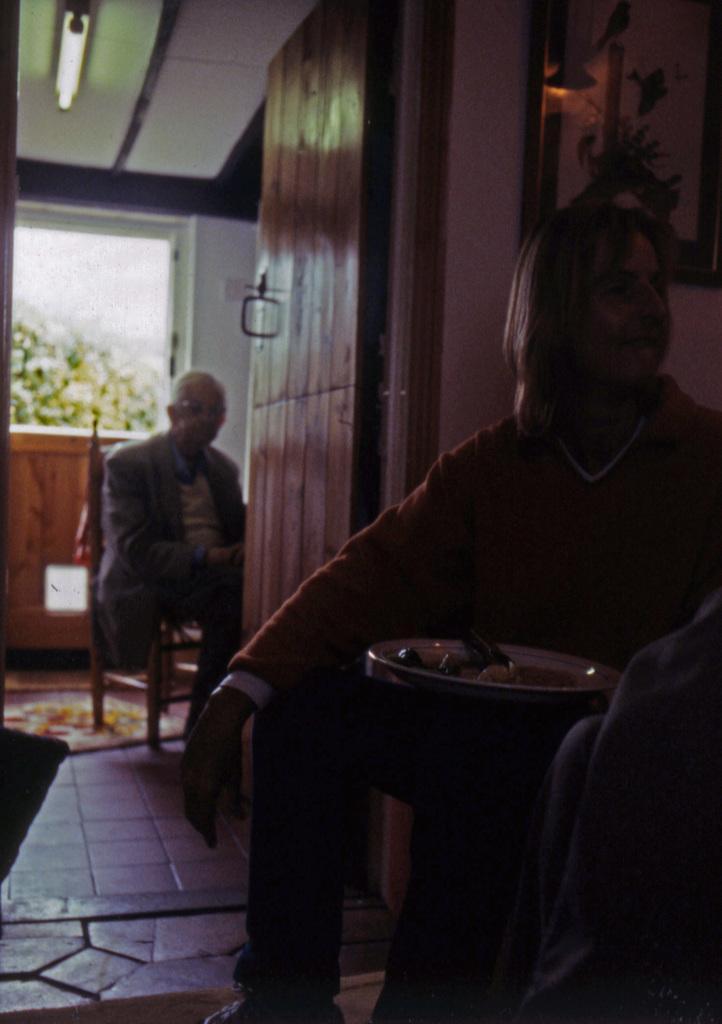How would you summarize this image in a sentence or two? There are two persons sitting on the chairs. This is floor and there is a mat. Here we can see a plate, frame, wall, glass, and a light. 